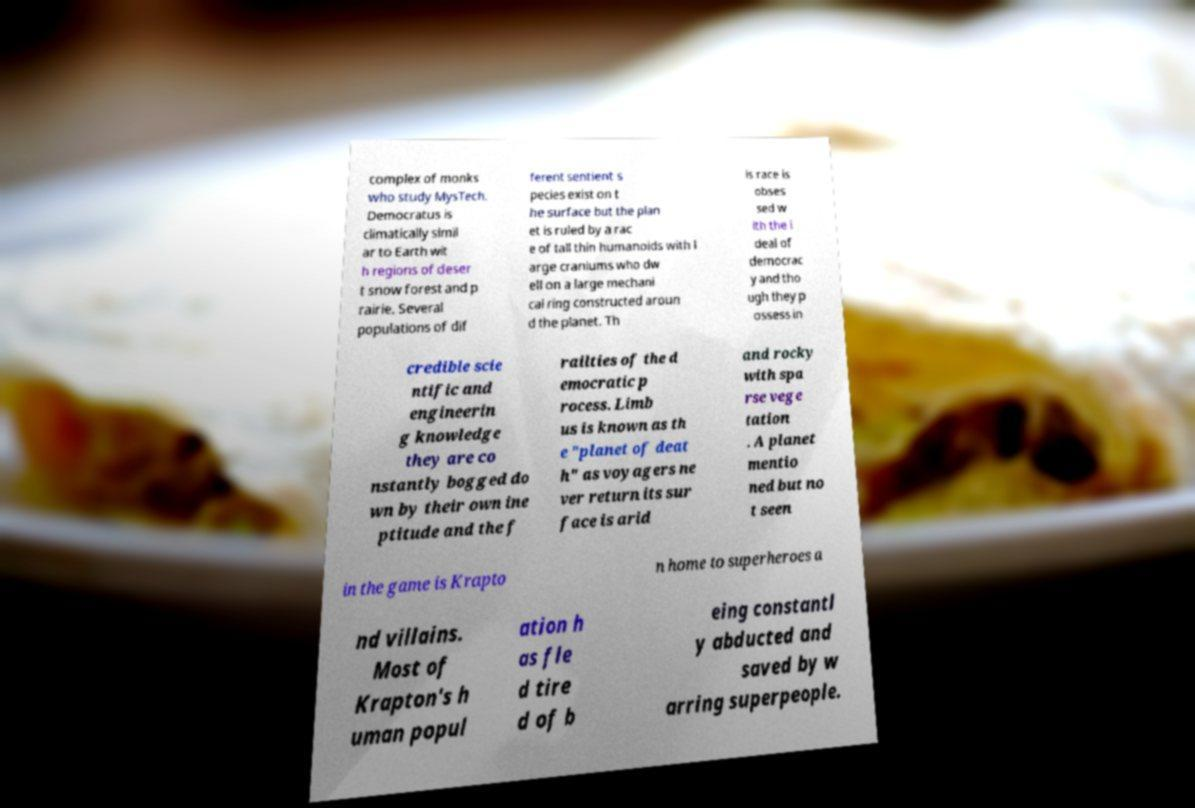Can you accurately transcribe the text from the provided image for me? complex of monks who study MysTech. Democratus is climatically simil ar to Earth wit h regions of deser t snow forest and p rairie. Several populations of dif ferent sentient s pecies exist on t he surface but the plan et is ruled by a rac e of tall thin humanoids with l arge craniums who dw ell on a large mechani cal ring constructed aroun d the planet. Th is race is obses sed w ith the i deal of democrac y and tho ugh they p ossess in credible scie ntific and engineerin g knowledge they are co nstantly bogged do wn by their own ine ptitude and the f railties of the d emocratic p rocess. Limb us is known as th e "planet of deat h" as voyagers ne ver return its sur face is arid and rocky with spa rse vege tation . A planet mentio ned but no t seen in the game is Krapto n home to superheroes a nd villains. Most of Krapton's h uman popul ation h as fle d tire d of b eing constantl y abducted and saved by w arring superpeople. 